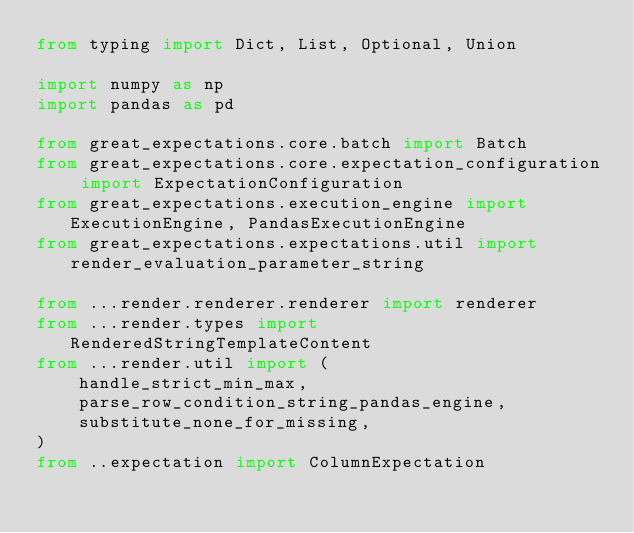Convert code to text. <code><loc_0><loc_0><loc_500><loc_500><_Python_>from typing import Dict, List, Optional, Union

import numpy as np
import pandas as pd

from great_expectations.core.batch import Batch
from great_expectations.core.expectation_configuration import ExpectationConfiguration
from great_expectations.execution_engine import ExecutionEngine, PandasExecutionEngine
from great_expectations.expectations.util import render_evaluation_parameter_string

from ...render.renderer.renderer import renderer
from ...render.types import RenderedStringTemplateContent
from ...render.util import (
    handle_strict_min_max,
    parse_row_condition_string_pandas_engine,
    substitute_none_for_missing,
)
from ..expectation import ColumnExpectation

</code> 